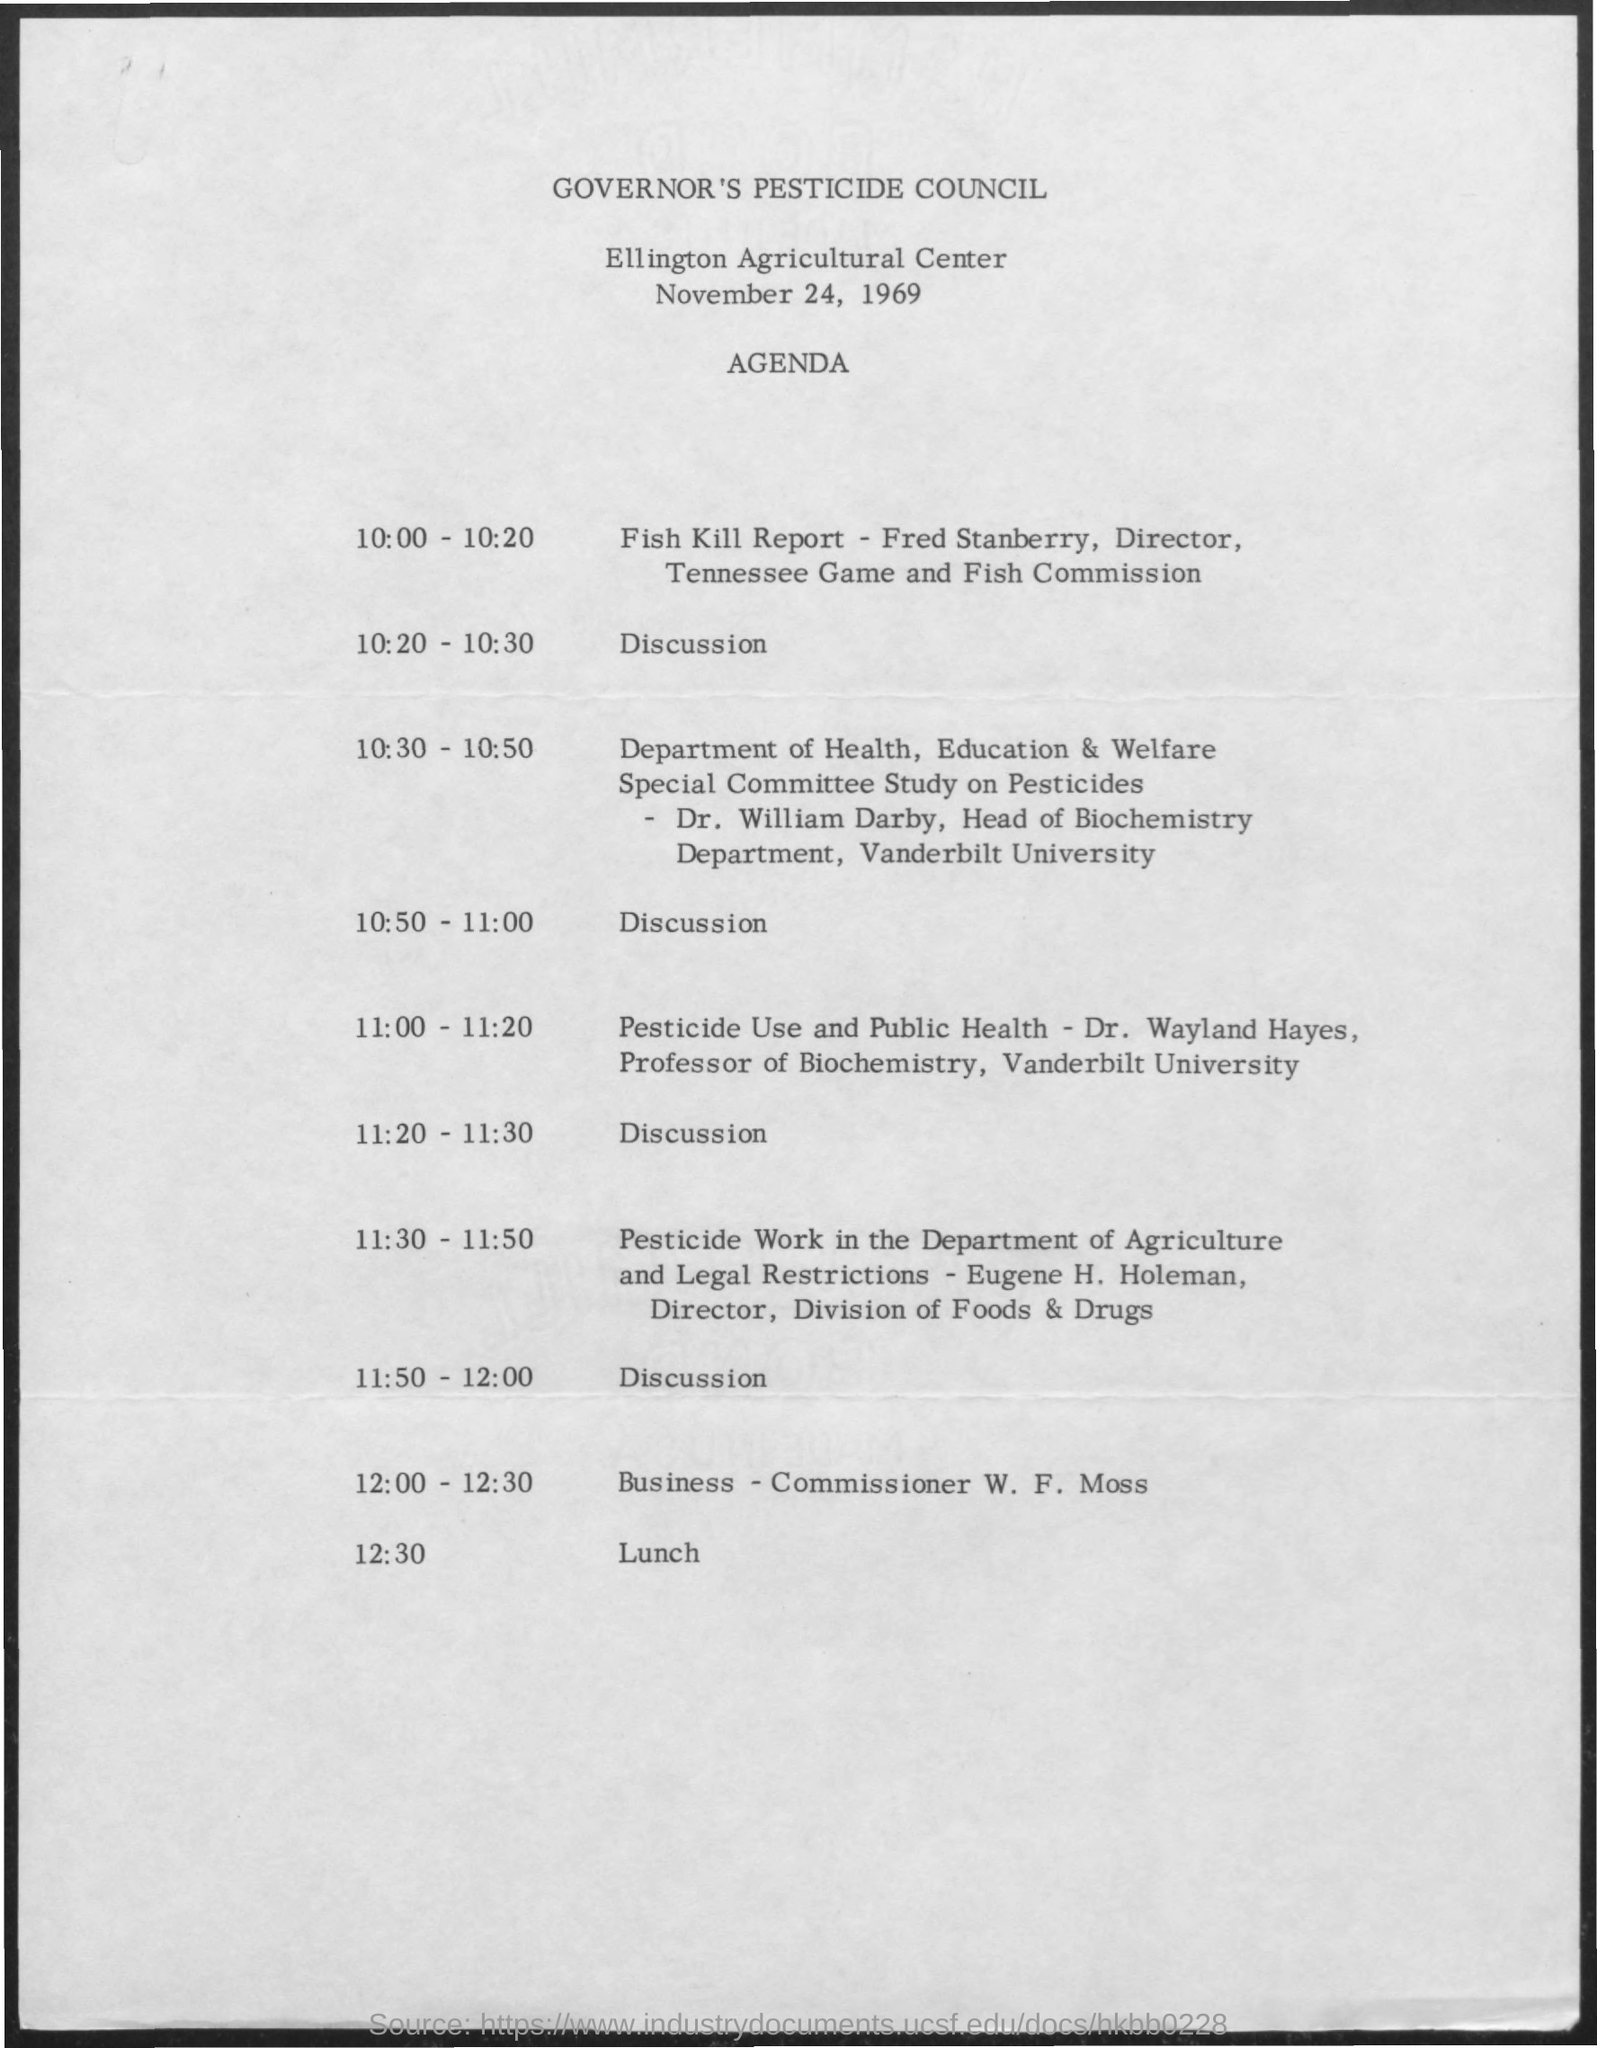When is the council held?
Offer a terse response. November 24, 1969. When is the Fish kill report?
Offer a terse response. 10:00-10:20. When is the lunch?
Make the answer very short. 12:30. 